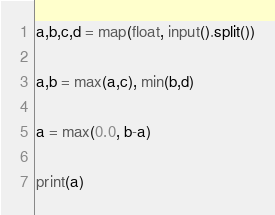<code> <loc_0><loc_0><loc_500><loc_500><_Python_>
a,b,c,d = map(float, input().split())

a,b = max(a,c), min(b,d)

a = max(0.0, b-a)

print(a)
</code> 